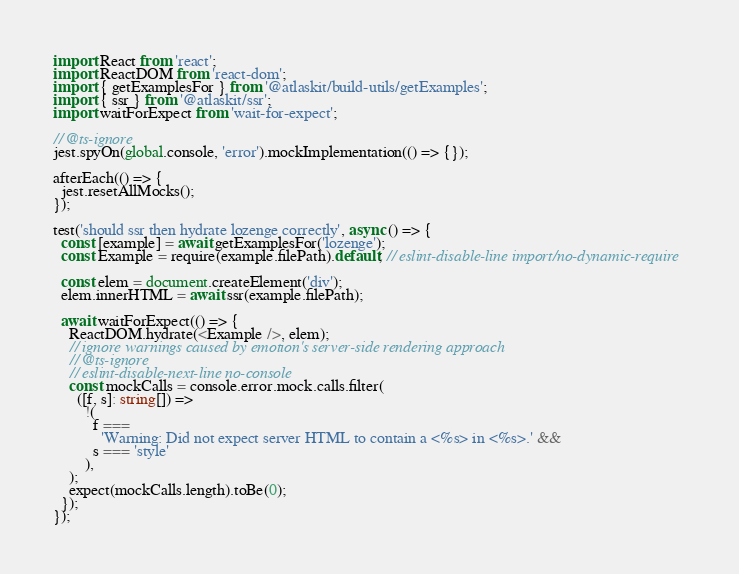<code> <loc_0><loc_0><loc_500><loc_500><_TypeScript_>import React from 'react';
import ReactDOM from 'react-dom';
import { getExamplesFor } from '@atlaskit/build-utils/getExamples';
import { ssr } from '@atlaskit/ssr';
import waitForExpect from 'wait-for-expect';

// @ts-ignore
jest.spyOn(global.console, 'error').mockImplementation(() => {});

afterEach(() => {
  jest.resetAllMocks();
});

test('should ssr then hydrate lozenge correctly', async () => {
  const [example] = await getExamplesFor('lozenge');
  const Example = require(example.filePath).default; // eslint-disable-line import/no-dynamic-require

  const elem = document.createElement('div');
  elem.innerHTML = await ssr(example.filePath);

  await waitForExpect(() => {
    ReactDOM.hydrate(<Example />, elem);
    // ignore warnings caused by emotion's server-side rendering approach
    // @ts-ignore
    // eslint-disable-next-line no-console
    const mockCalls = console.error.mock.calls.filter(
      ([f, s]: string[]) =>
        !(
          f ===
            'Warning: Did not expect server HTML to contain a <%s> in <%s>.' &&
          s === 'style'
        ),
    );
    expect(mockCalls.length).toBe(0);
  });
});
</code> 